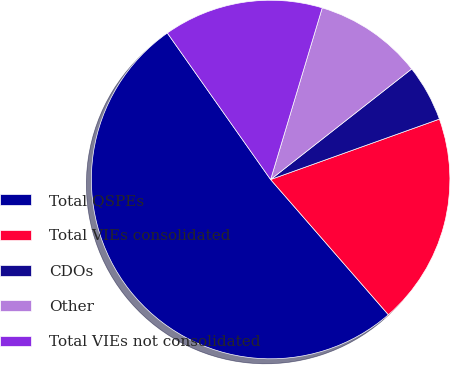Convert chart to OTSL. <chart><loc_0><loc_0><loc_500><loc_500><pie_chart><fcel>Total QSPEs<fcel>Total VIEs consolidated<fcel>CDOs<fcel>Other<fcel>Total VIEs not consolidated<nl><fcel>51.63%<fcel>19.07%<fcel>5.11%<fcel>9.77%<fcel>14.42%<nl></chart> 